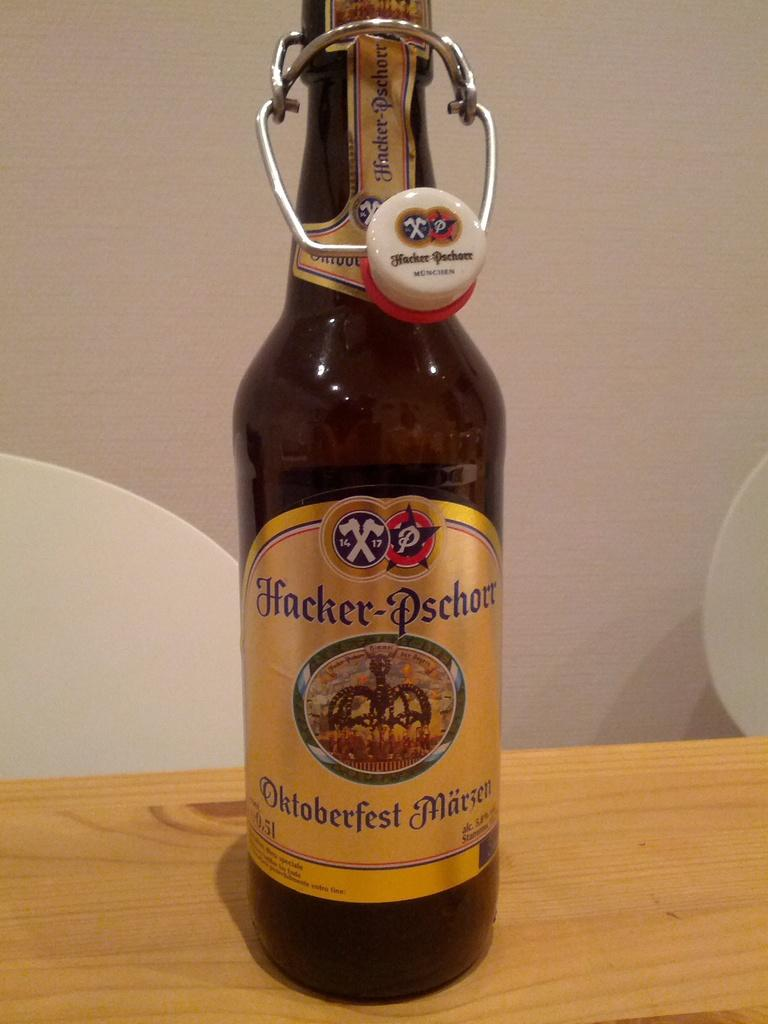<image>
Present a compact description of the photo's key features. A beer called Oktoberfest Marzen features a fancy cap 